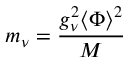Convert formula to latex. <formula><loc_0><loc_0><loc_500><loc_500>m _ { \nu } = \frac { g _ { \nu } ^ { 2 } \langle \Phi \rangle ^ { 2 } } { M }</formula> 